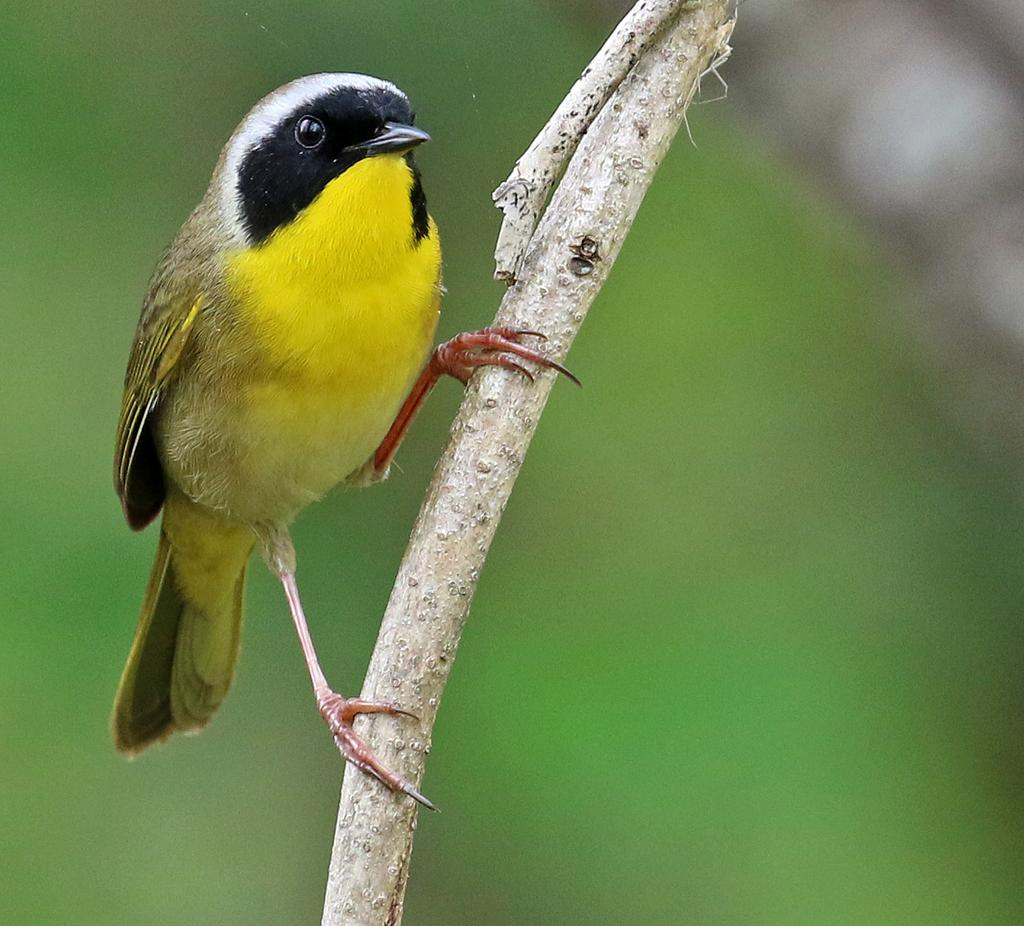What type of animal can be seen in the image? There is a bird in the image. Where is the bird located? The bird is on a wooden branch. What color is the bird? The bird is yellow in color. Can you describe the background of the image? The background of the image is blurred. What is the plot of the story being told in the image? There is no story being told in the image, as it is a photograph of a bird on a wooden branch. How does the bird's digestion process work in the image? The image does not show the bird's digestion process, as it is focused on the bird's appearance and location. 